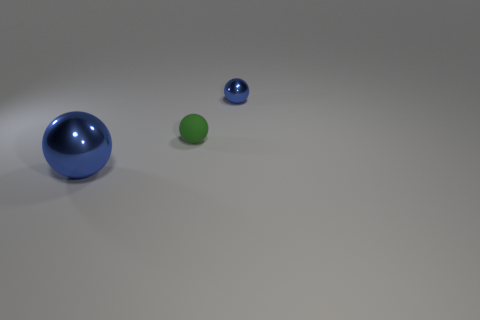Add 3 small rubber things. How many objects exist? 6 Add 2 tiny blue shiny spheres. How many tiny blue shiny spheres exist? 3 Subtract 0 cyan cylinders. How many objects are left? 3 Subtract all green rubber things. Subtract all big balls. How many objects are left? 1 Add 3 balls. How many balls are left? 6 